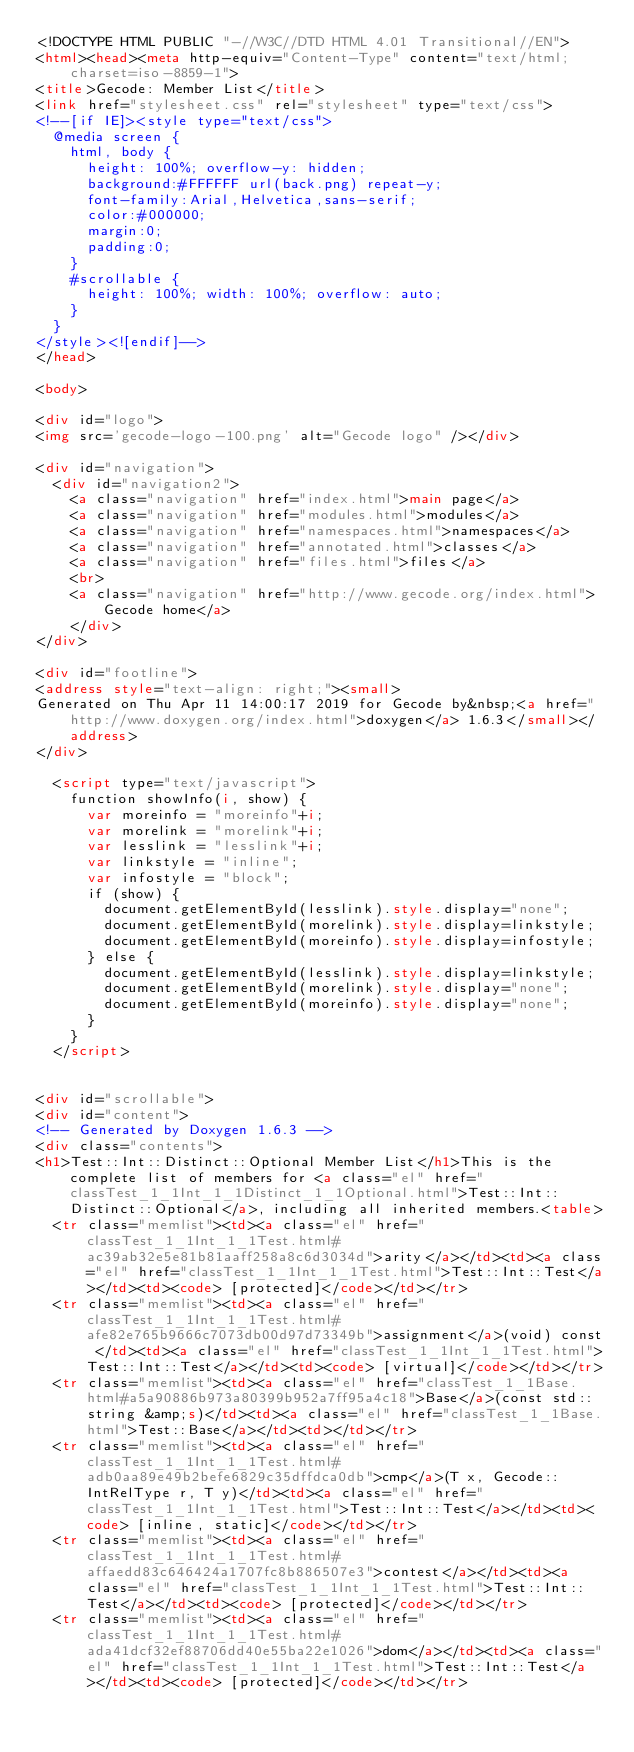<code> <loc_0><loc_0><loc_500><loc_500><_HTML_><!DOCTYPE HTML PUBLIC "-//W3C//DTD HTML 4.01 Transitional//EN">
<html><head><meta http-equiv="Content-Type" content="text/html;charset=iso-8859-1">
<title>Gecode: Member List</title>
<link href="stylesheet.css" rel="stylesheet" type="text/css">
<!--[if IE]><style type="text/css">
  @media screen {
    html, body {
      height: 100%; overflow-y: hidden;
      background:#FFFFFF url(back.png) repeat-y;
      font-family:Arial,Helvetica,sans-serif;
      color:#000000;
      margin:0;
      padding:0;
    }
    #scrollable {
      height: 100%; width: 100%; overflow: auto;
    }
  }
</style><![endif]-->
</head>

<body>

<div id="logo">
<img src='gecode-logo-100.png' alt="Gecode logo" /></div>

<div id="navigation">
  <div id="navigation2">
    <a class="navigation" href="index.html">main page</a>
    <a class="navigation" href="modules.html">modules</a>
    <a class="navigation" href="namespaces.html">namespaces</a>
    <a class="navigation" href="annotated.html">classes</a>
    <a class="navigation" href="files.html">files</a>
    <br>
    <a class="navigation" href="http://www.gecode.org/index.html">Gecode home</a>
    </div>
</div>

<div id="footline">
<address style="text-align: right;"><small>
Generated on Thu Apr 11 14:00:17 2019 for Gecode by&nbsp;<a href="http://www.doxygen.org/index.html">doxygen</a> 1.6.3</small></address>
</div>

  <script type="text/javascript">
    function showInfo(i, show) {
      var moreinfo = "moreinfo"+i;
      var morelink = "morelink"+i;
      var lesslink = "lesslink"+i;
      var linkstyle = "inline";
      var infostyle = "block";
      if (show) {
        document.getElementById(lesslink).style.display="none";
        document.getElementById(morelink).style.display=linkstyle;
        document.getElementById(moreinfo).style.display=infostyle;
      } else {
        document.getElementById(lesslink).style.display=linkstyle;
        document.getElementById(morelink).style.display="none";
        document.getElementById(moreinfo).style.display="none";
      }
    }
  </script>


<div id="scrollable">
<div id="content">
<!-- Generated by Doxygen 1.6.3 -->
<div class="contents">
<h1>Test::Int::Distinct::Optional Member List</h1>This is the complete list of members for <a class="el" href="classTest_1_1Int_1_1Distinct_1_1Optional.html">Test::Int::Distinct::Optional</a>, including all inherited members.<table>
  <tr class="memlist"><td><a class="el" href="classTest_1_1Int_1_1Test.html#ac39ab32e5e81b81aaff258a8c6d3034d">arity</a></td><td><a class="el" href="classTest_1_1Int_1_1Test.html">Test::Int::Test</a></td><td><code> [protected]</code></td></tr>
  <tr class="memlist"><td><a class="el" href="classTest_1_1Int_1_1Test.html#afe82e765b9666c7073db00d97d73349b">assignment</a>(void) const </td><td><a class="el" href="classTest_1_1Int_1_1Test.html">Test::Int::Test</a></td><td><code> [virtual]</code></td></tr>
  <tr class="memlist"><td><a class="el" href="classTest_1_1Base.html#a5a90886b973a80399b952a7ff95a4c18">Base</a>(const std::string &amp;s)</td><td><a class="el" href="classTest_1_1Base.html">Test::Base</a></td><td></td></tr>
  <tr class="memlist"><td><a class="el" href="classTest_1_1Int_1_1Test.html#adb0aa89e49b2befe6829c35dffdca0db">cmp</a>(T x, Gecode::IntRelType r, T y)</td><td><a class="el" href="classTest_1_1Int_1_1Test.html">Test::Int::Test</a></td><td><code> [inline, static]</code></td></tr>
  <tr class="memlist"><td><a class="el" href="classTest_1_1Int_1_1Test.html#affaedd83c646424a1707fc8b886507e3">contest</a></td><td><a class="el" href="classTest_1_1Int_1_1Test.html">Test::Int::Test</a></td><td><code> [protected]</code></td></tr>
  <tr class="memlist"><td><a class="el" href="classTest_1_1Int_1_1Test.html#ada41dcf32ef88706dd40e55ba22e1026">dom</a></td><td><a class="el" href="classTest_1_1Int_1_1Test.html">Test::Int::Test</a></td><td><code> [protected]</code></td></tr></code> 